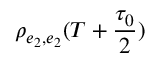Convert formula to latex. <formula><loc_0><loc_0><loc_500><loc_500>\rho _ { e _ { 2 } , e _ { 2 } } ( T + \frac { \tau _ { 0 } } { 2 } )</formula> 